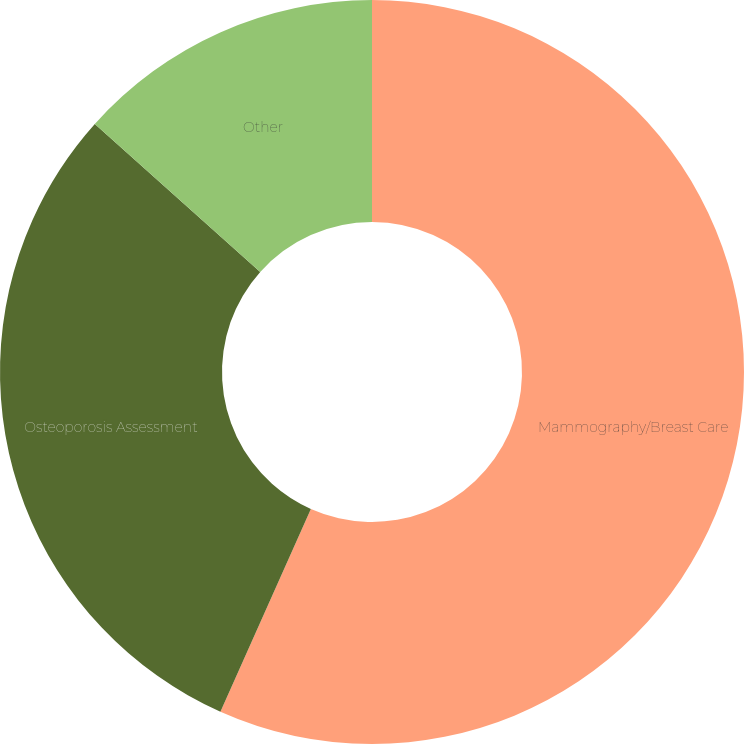Convert chart to OTSL. <chart><loc_0><loc_0><loc_500><loc_500><pie_chart><fcel>Mammography/Breast Care<fcel>Osteoporosis Assessment<fcel>Other<nl><fcel>56.68%<fcel>29.94%<fcel>13.38%<nl></chart> 